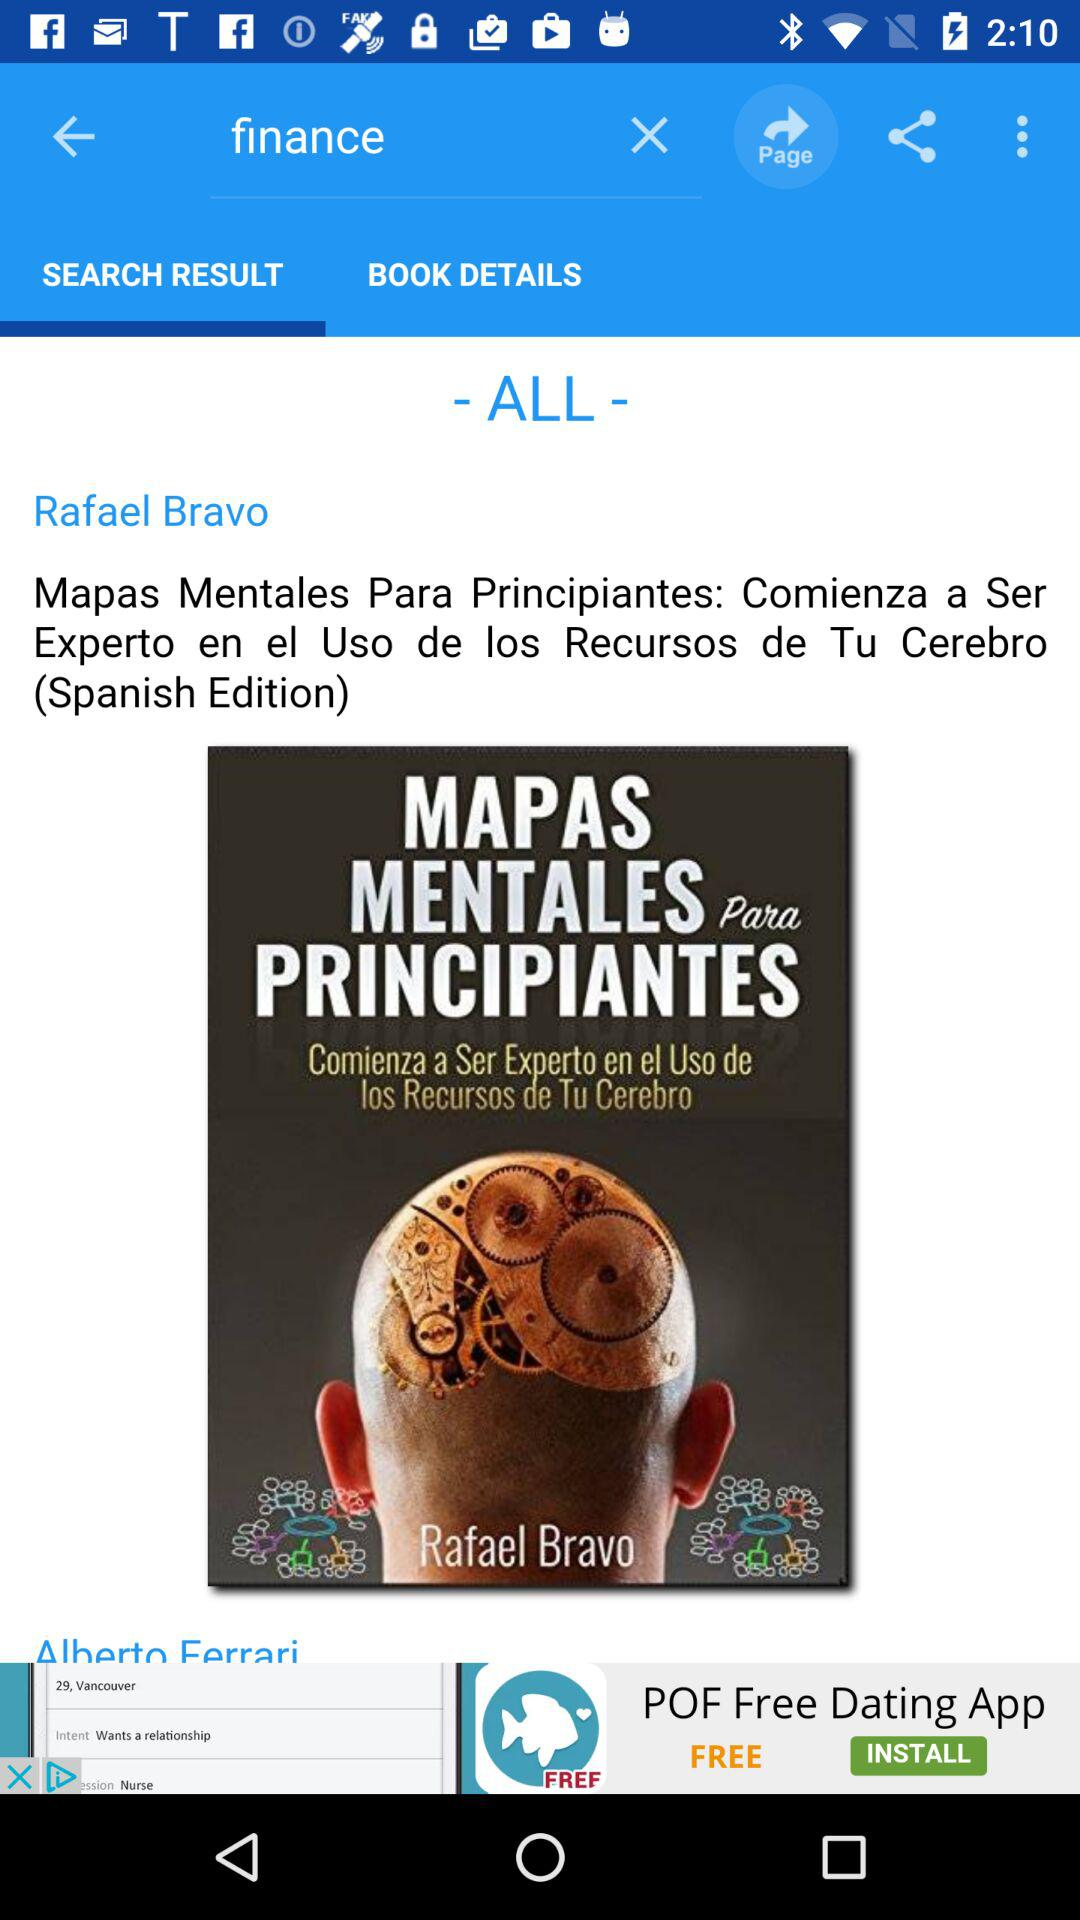What is the selected tab? The selected tab is "SEARCH RESULT". 